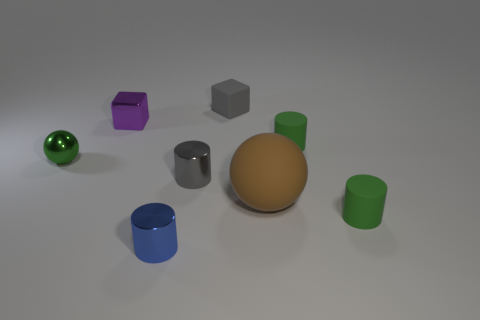Add 2 matte blocks. How many objects exist? 10 Subtract all cubes. How many objects are left? 6 Add 6 tiny blue metallic spheres. How many tiny blue metallic spheres exist? 6 Subtract 0 purple cylinders. How many objects are left? 8 Subtract all cyan metallic cylinders. Subtract all small green spheres. How many objects are left? 7 Add 5 gray objects. How many gray objects are left? 7 